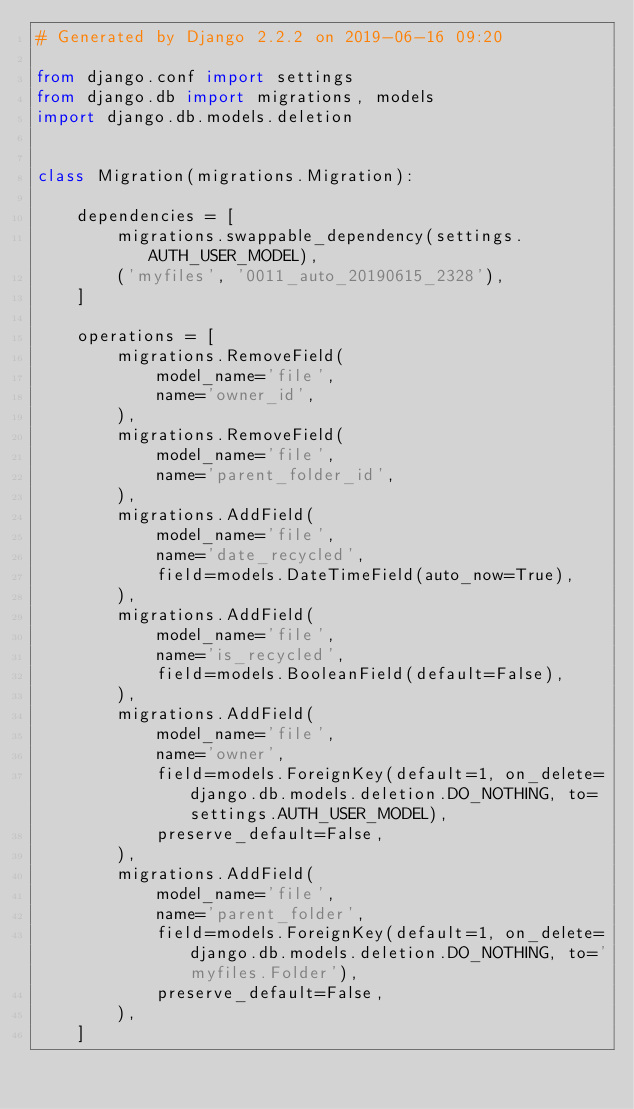<code> <loc_0><loc_0><loc_500><loc_500><_Python_># Generated by Django 2.2.2 on 2019-06-16 09:20

from django.conf import settings
from django.db import migrations, models
import django.db.models.deletion


class Migration(migrations.Migration):

    dependencies = [
        migrations.swappable_dependency(settings.AUTH_USER_MODEL),
        ('myfiles', '0011_auto_20190615_2328'),
    ]

    operations = [
        migrations.RemoveField(
            model_name='file',
            name='owner_id',
        ),
        migrations.RemoveField(
            model_name='file',
            name='parent_folder_id',
        ),
        migrations.AddField(
            model_name='file',
            name='date_recycled',
            field=models.DateTimeField(auto_now=True),
        ),
        migrations.AddField(
            model_name='file',
            name='is_recycled',
            field=models.BooleanField(default=False),
        ),
        migrations.AddField(
            model_name='file',
            name='owner',
            field=models.ForeignKey(default=1, on_delete=django.db.models.deletion.DO_NOTHING, to=settings.AUTH_USER_MODEL),
            preserve_default=False,
        ),
        migrations.AddField(
            model_name='file',
            name='parent_folder',
            field=models.ForeignKey(default=1, on_delete=django.db.models.deletion.DO_NOTHING, to='myfiles.Folder'),
            preserve_default=False,
        ),
    ]
</code> 